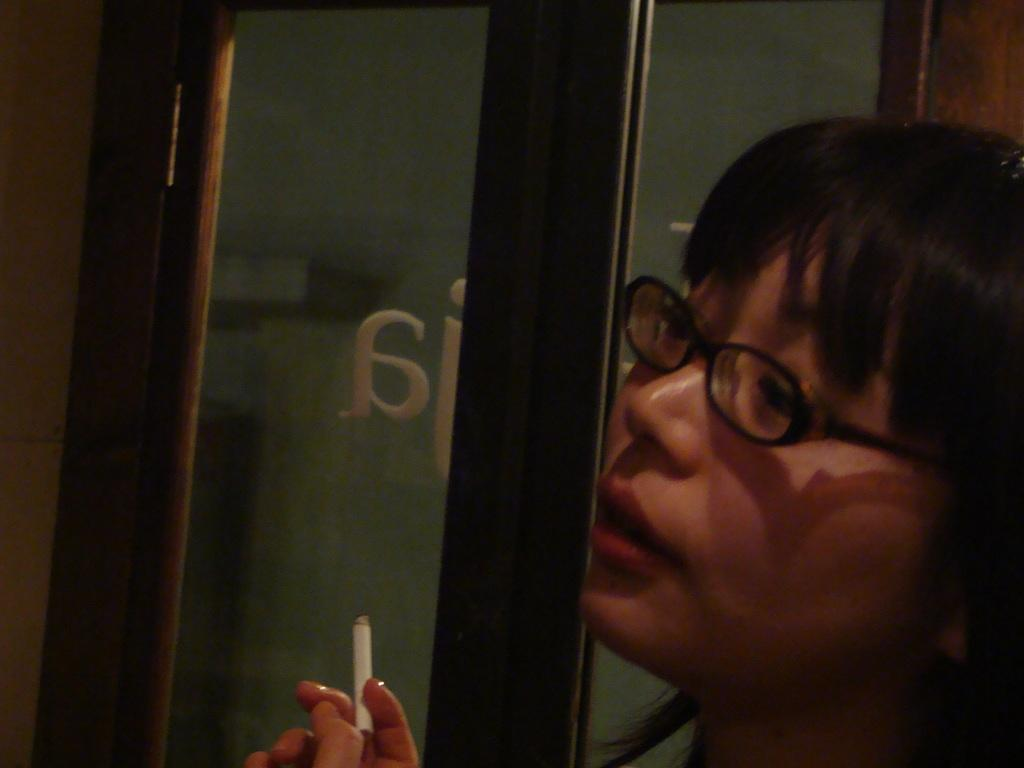What can be seen in the image? There is a person in the image. Can you describe the person's appearance? The person is wearing spectacles. What is the person holding in their hands? The person is holding a cigarette in their hands. Is there any text visible in the image? Yes, there is text visible in the image. How many rabbits are present in the image? There are no rabbits present in the image. What type of polish is being applied to the person's nails in the image? There is no indication of nail polish or any polishing activity in the image. 